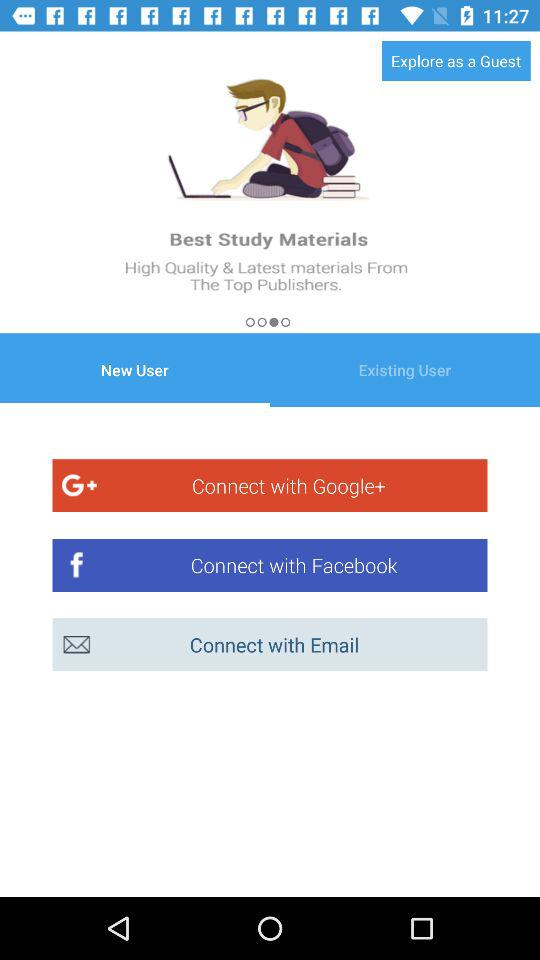Which is the selected application to connect?
When the provided information is insufficient, respond with <no answer>. <no answer> 